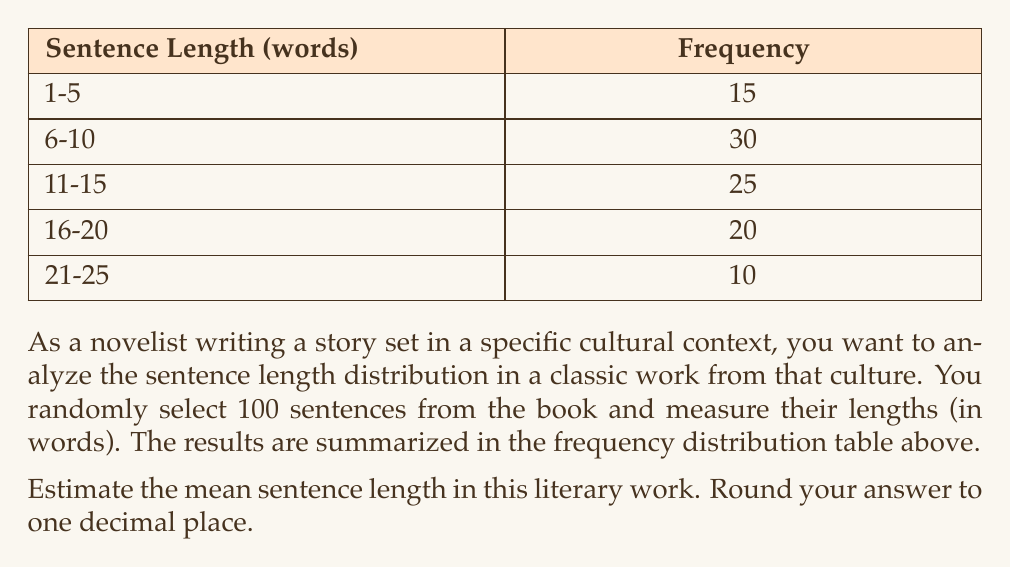Give your solution to this math problem. To estimate the mean sentence length, we'll use the midpoint of each class interval as a representative value and calculate the weighted average.

Step 1: Determine the midpoint of each class interval.
- 1-5: $(1+5)/2 = 3$
- 6-10: $(6+10)/2 = 8$
- 11-15: $(11+15)/2 = 13$
- 16-20: $(16+20)/2 = 18$
- 21-25: $(21+25)/2 = 23$

Step 2: Calculate the sum of the products of midpoints and frequencies.
$$(3 \times 15) + (8 \times 30) + (13 \times 25) + (18 \times 20) + (23 \times 10) = 45 + 240 + 325 + 360 + 230 = 1200$$

Step 3: Calculate the total number of sentences.
$$15 + 30 + 25 + 20 + 10 = 100$$

Step 4: Calculate the mean by dividing the sum from Step 2 by the total number of sentences.
$$\text{Mean} = \frac{1200}{100} = 12$$

Step 5: Round to one decimal place.
The result is already a whole number, so it remains 12.0.
Answer: 12.0 words 